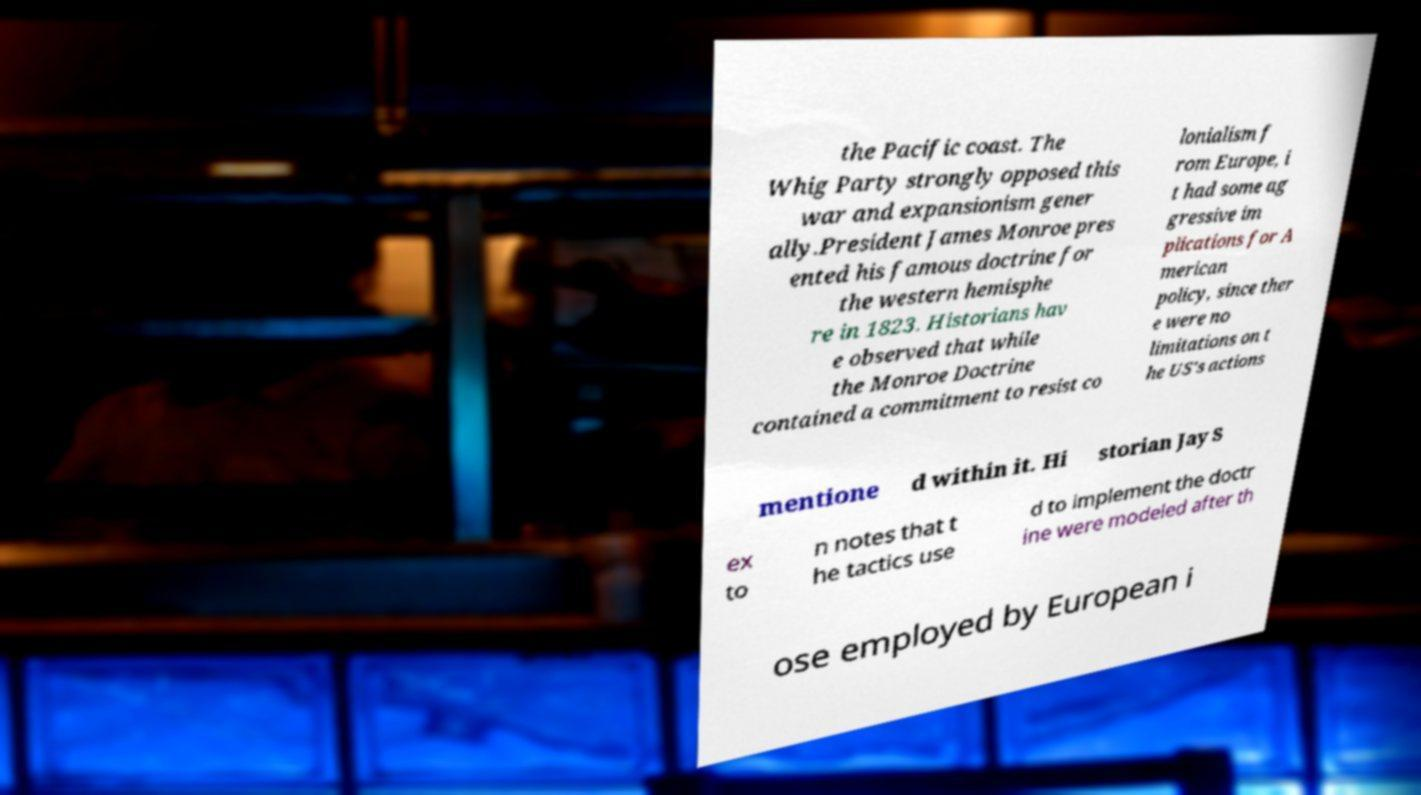I need the written content from this picture converted into text. Can you do that? the Pacific coast. The Whig Party strongly opposed this war and expansionism gener ally.President James Monroe pres ented his famous doctrine for the western hemisphe re in 1823. Historians hav e observed that while the Monroe Doctrine contained a commitment to resist co lonialism f rom Europe, i t had some ag gressive im plications for A merican policy, since ther e were no limitations on t he US's actions mentione d within it. Hi storian Jay S ex to n notes that t he tactics use d to implement the doctr ine were modeled after th ose employed by European i 